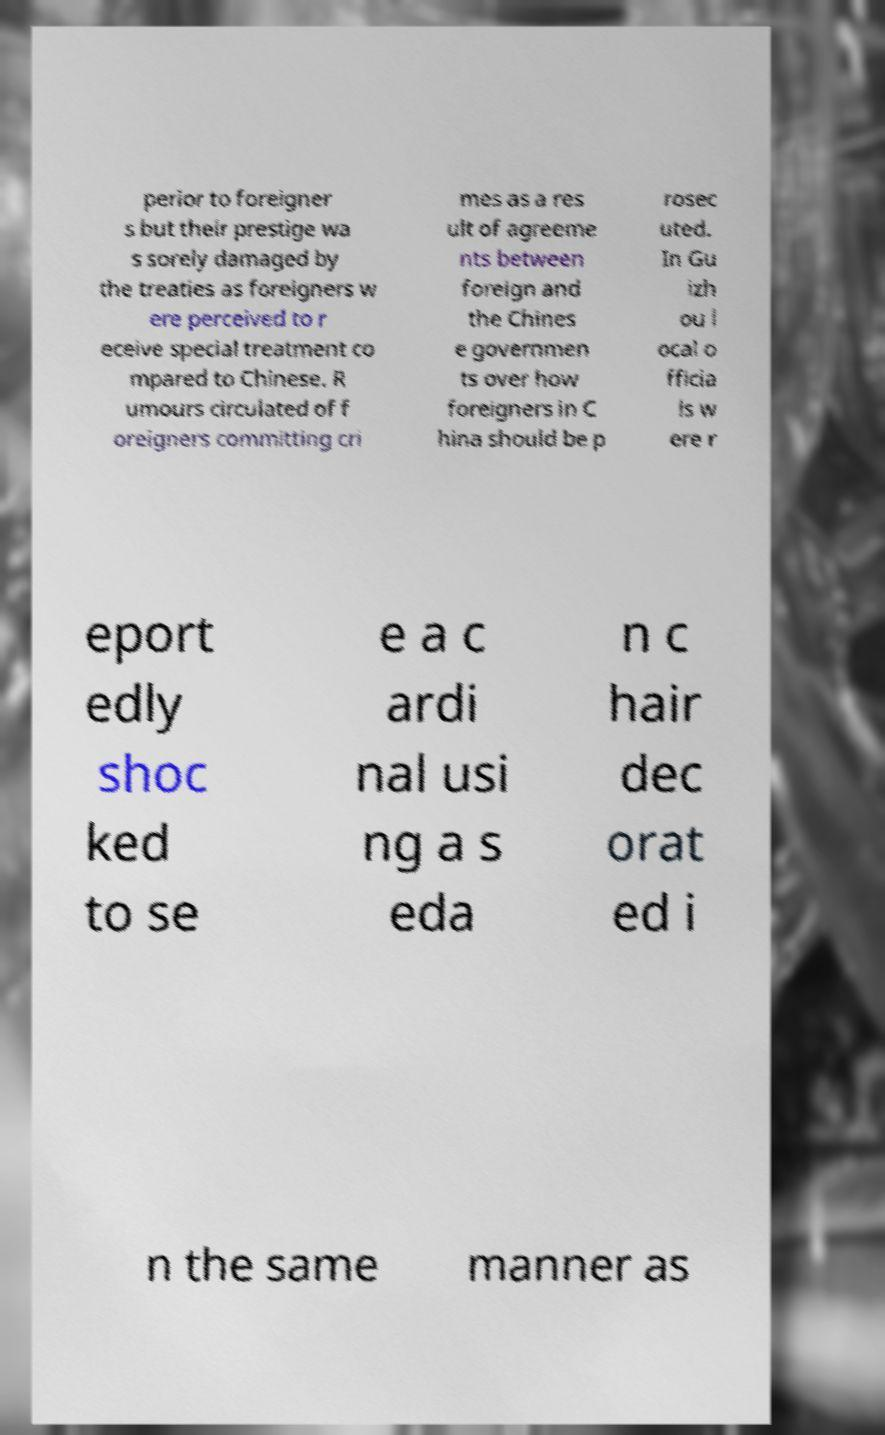Please identify and transcribe the text found in this image. perior to foreigner s but their prestige wa s sorely damaged by the treaties as foreigners w ere perceived to r eceive special treatment co mpared to Chinese. R umours circulated of f oreigners committing cri mes as a res ult of agreeme nts between foreign and the Chines e governmen ts over how foreigners in C hina should be p rosec uted. In Gu izh ou l ocal o fficia ls w ere r eport edly shoc ked to se e a c ardi nal usi ng a s eda n c hair dec orat ed i n the same manner as 